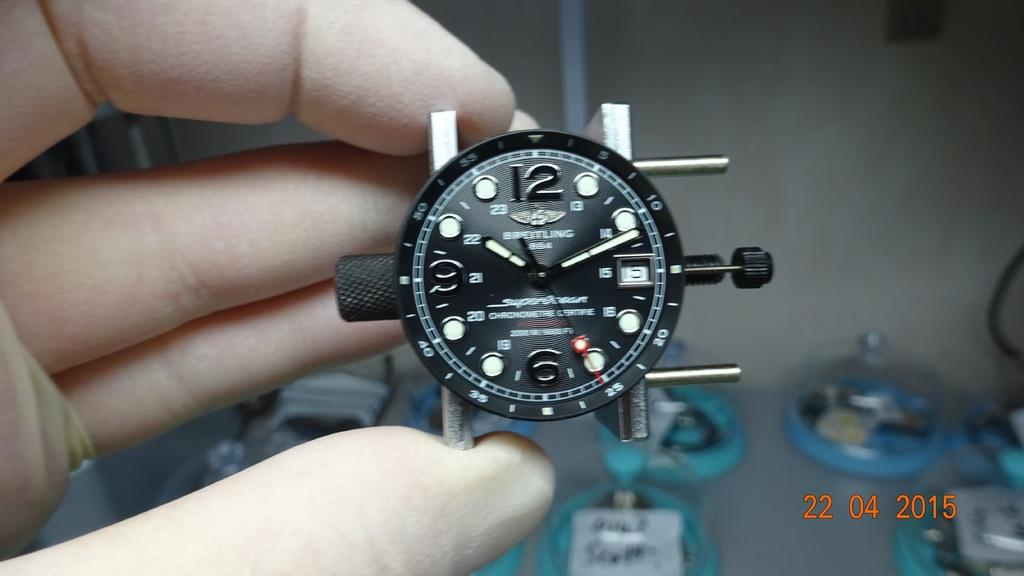<image>
Relay a brief, clear account of the picture shown. A Breitling brand watch is shown with no band. 